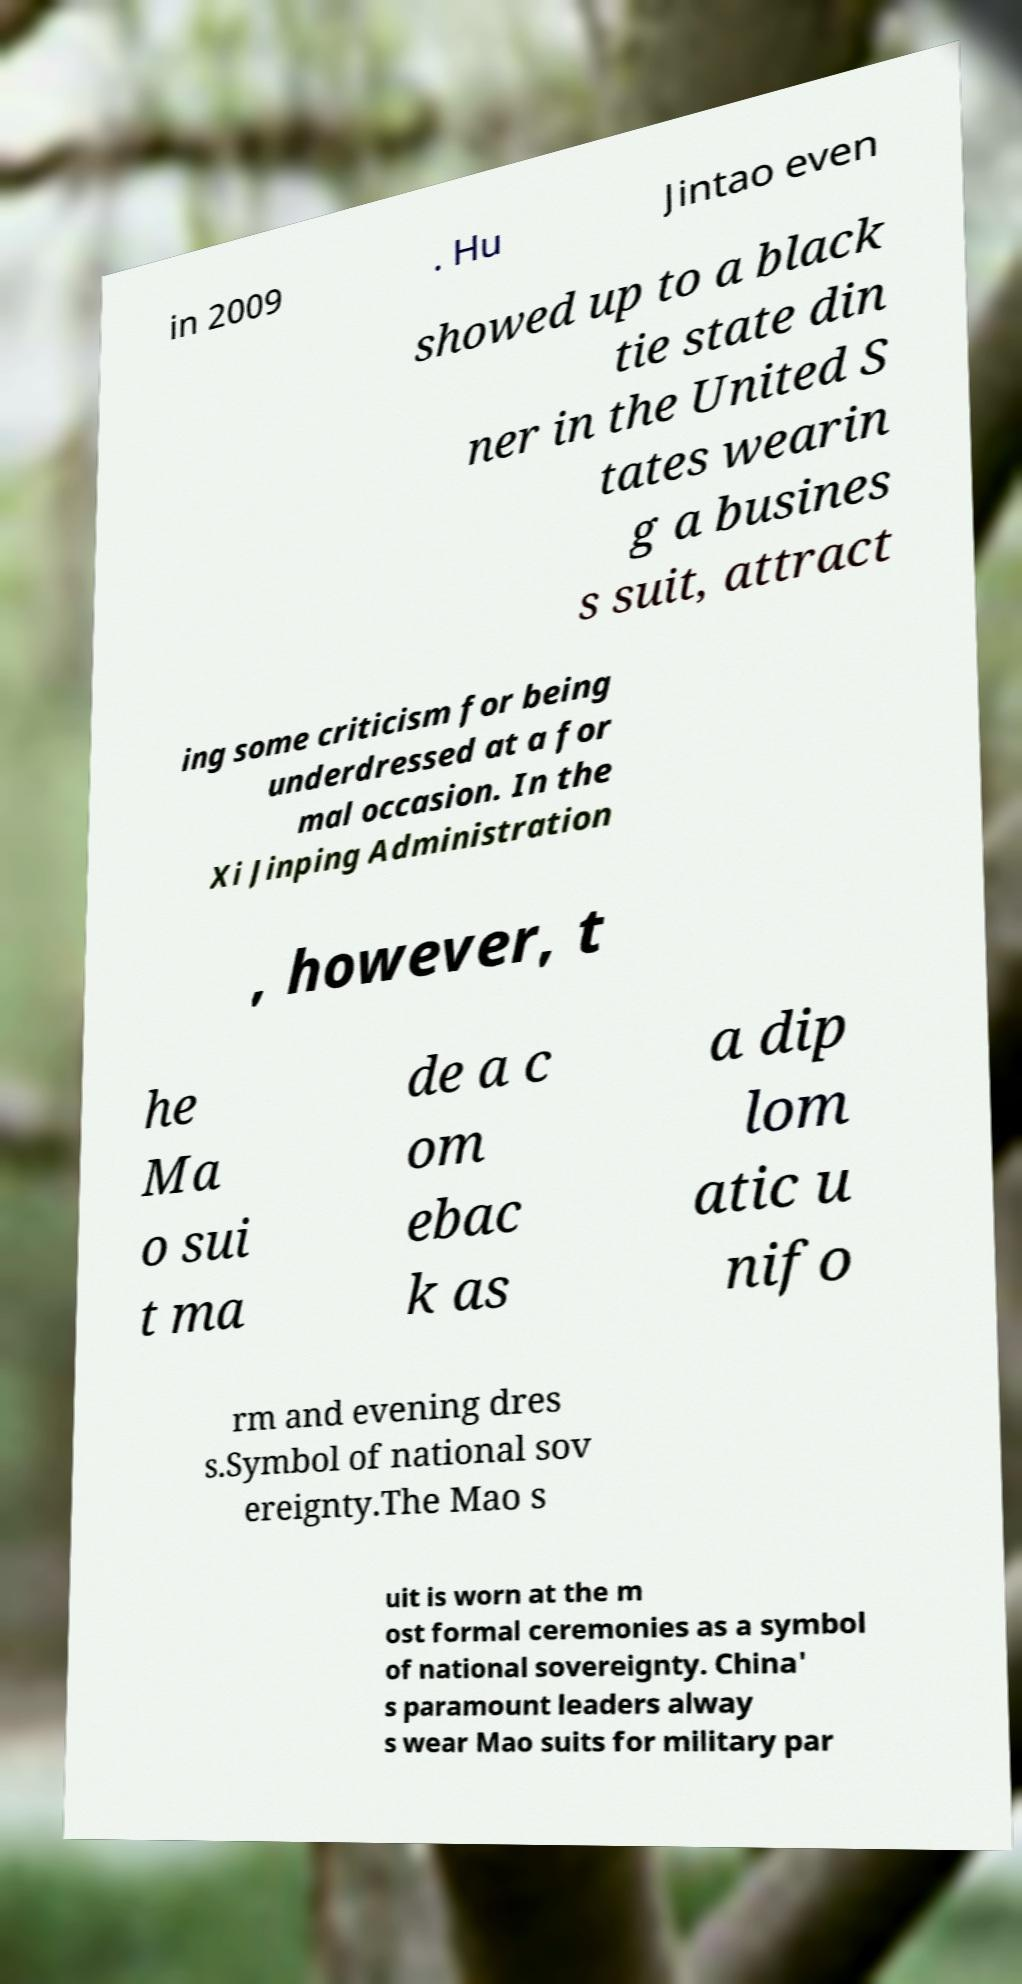Could you assist in decoding the text presented in this image and type it out clearly? in 2009 . Hu Jintao even showed up to a black tie state din ner in the United S tates wearin g a busines s suit, attract ing some criticism for being underdressed at a for mal occasion. In the Xi Jinping Administration , however, t he Ma o sui t ma de a c om ebac k as a dip lom atic u nifo rm and evening dres s.Symbol of national sov ereignty.The Mao s uit is worn at the m ost formal ceremonies as a symbol of national sovereignty. China' s paramount leaders alway s wear Mao suits for military par 